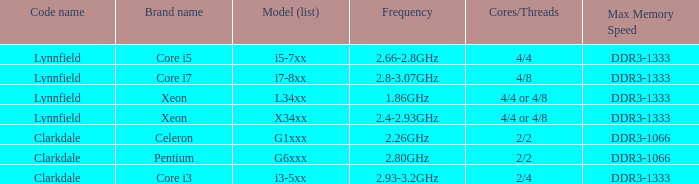8ghz. 4/4. 